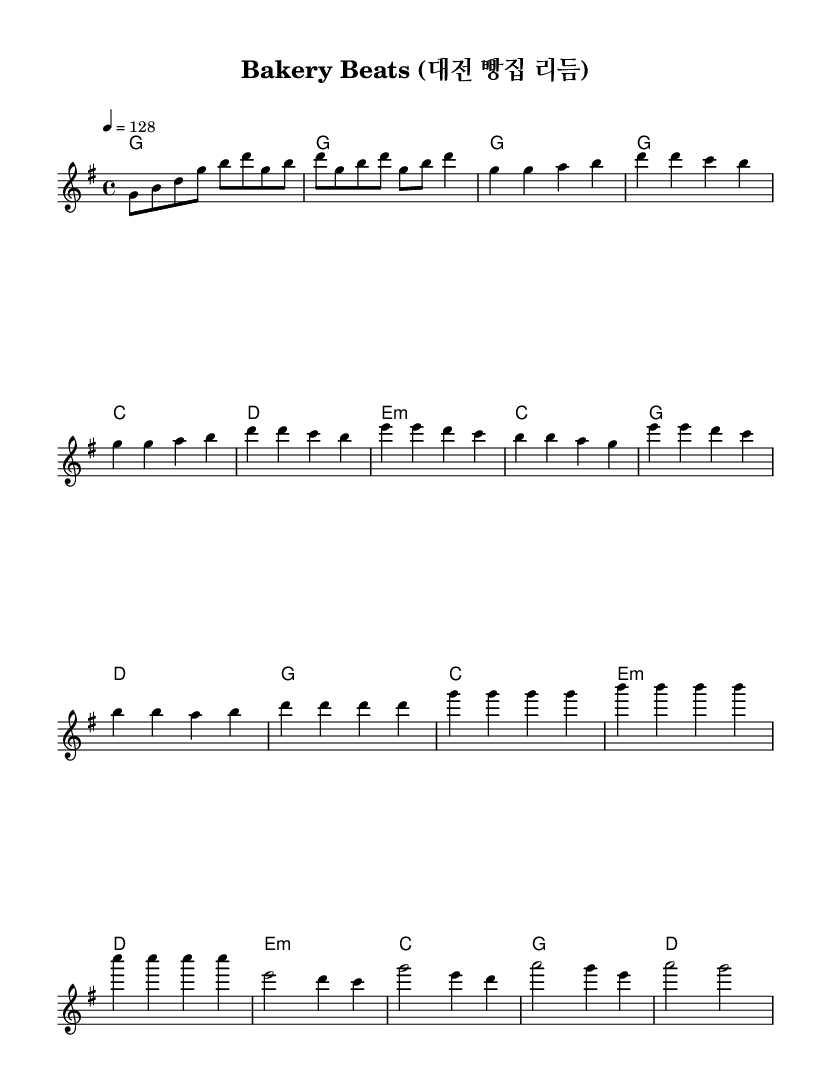What is the key signature of this music? The key signature is G major, indicated by one sharp on the staff.
Answer: G major What is the time signature of this music? The time signature is four-four time, as shown at the beginning of the score.
Answer: Four-four What is the tempo marking for this piece? The tempo marking indicates a speed of 128 beats per minute, stated in the tempo section at the top.
Answer: 128 How many measures are in the chorus section? The chorus section consists of four measures, which can be counted from the score's structure in that section.
Answer: Four measures What type of chords are present in the pre-chorus? The chords in the pre-chorus include minor and major chords, specifically E minor, C major, G major, and D major.
Answer: Minor and major What is the primary theme of the song as suggested by the lyrics? The lyrics celebrate Daejeon's bakery culture, highlighting the deliciousness and pride in local baked goods.
Answer: Local cuisine Which note is the highest in the melody? The highest note in the melody is A, found in the bridge section of the piece.
Answer: A 